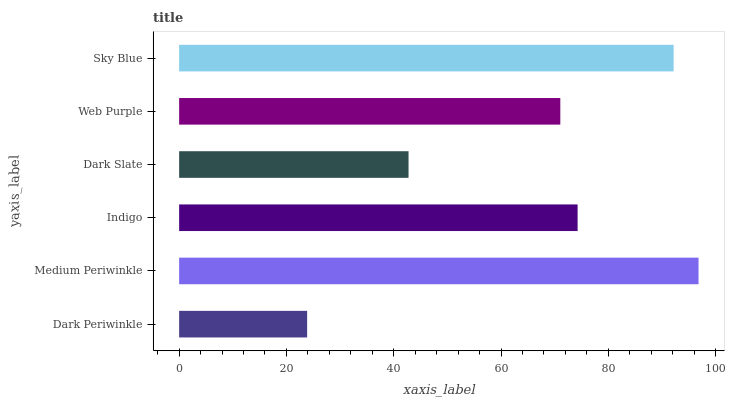Is Dark Periwinkle the minimum?
Answer yes or no. Yes. Is Medium Periwinkle the maximum?
Answer yes or no. Yes. Is Indigo the minimum?
Answer yes or no. No. Is Indigo the maximum?
Answer yes or no. No. Is Medium Periwinkle greater than Indigo?
Answer yes or no. Yes. Is Indigo less than Medium Periwinkle?
Answer yes or no. Yes. Is Indigo greater than Medium Periwinkle?
Answer yes or no. No. Is Medium Periwinkle less than Indigo?
Answer yes or no. No. Is Indigo the high median?
Answer yes or no. Yes. Is Web Purple the low median?
Answer yes or no. Yes. Is Medium Periwinkle the high median?
Answer yes or no. No. Is Dark Slate the low median?
Answer yes or no. No. 